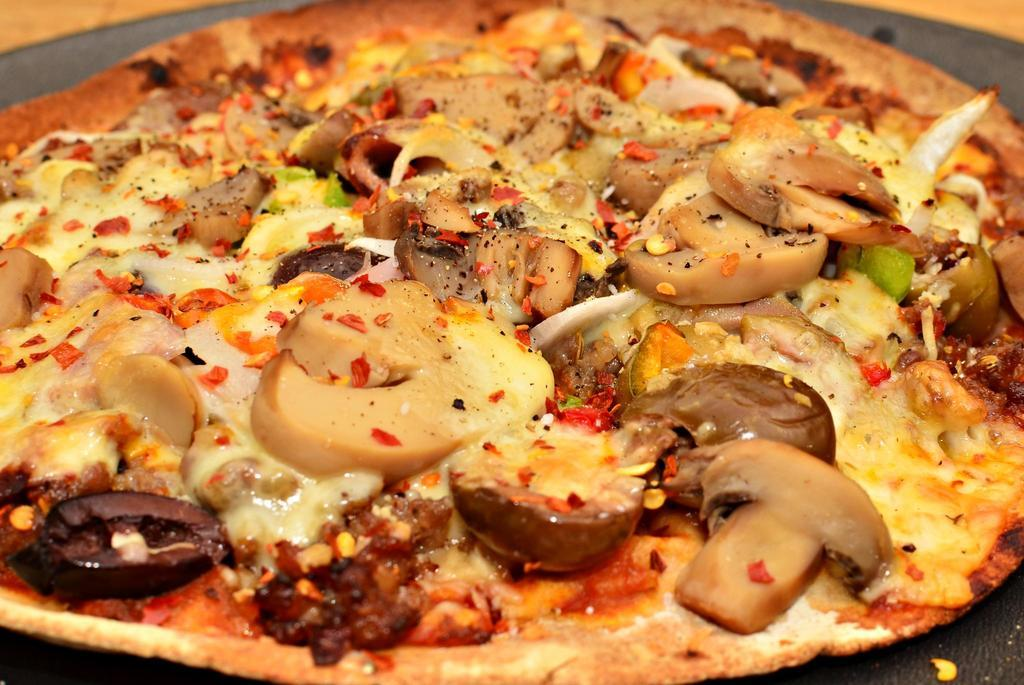What type of food is the main subject of the image? There is a pizza in the image. What specific toppings can be seen on the pizza? The pizza has mushrooms, cheese, and chili flakes on it. Are there any other ingredients on the pizza? Yes, there are other ingredients on the pizza. On what object is the pizza placed in the image? The pizza is on an object, such as a plate or a cutting board. What type of sticks are used to stir the soup in the image? There is no soup or sticks present in the image; it features a pizza with various toppings. 